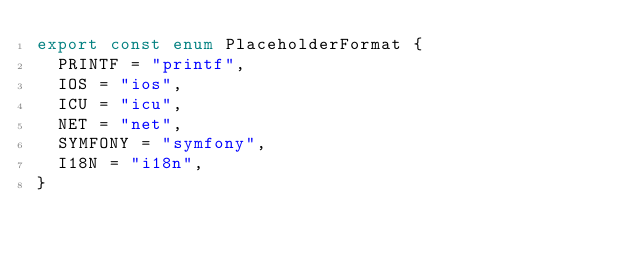<code> <loc_0><loc_0><loc_500><loc_500><_TypeScript_>export const enum PlaceholderFormat {
  PRINTF = "printf",
  IOS = "ios",
  ICU = "icu",
  NET = "net",
  SYMFONY = "symfony",
  I18N = "i18n",
}
</code> 